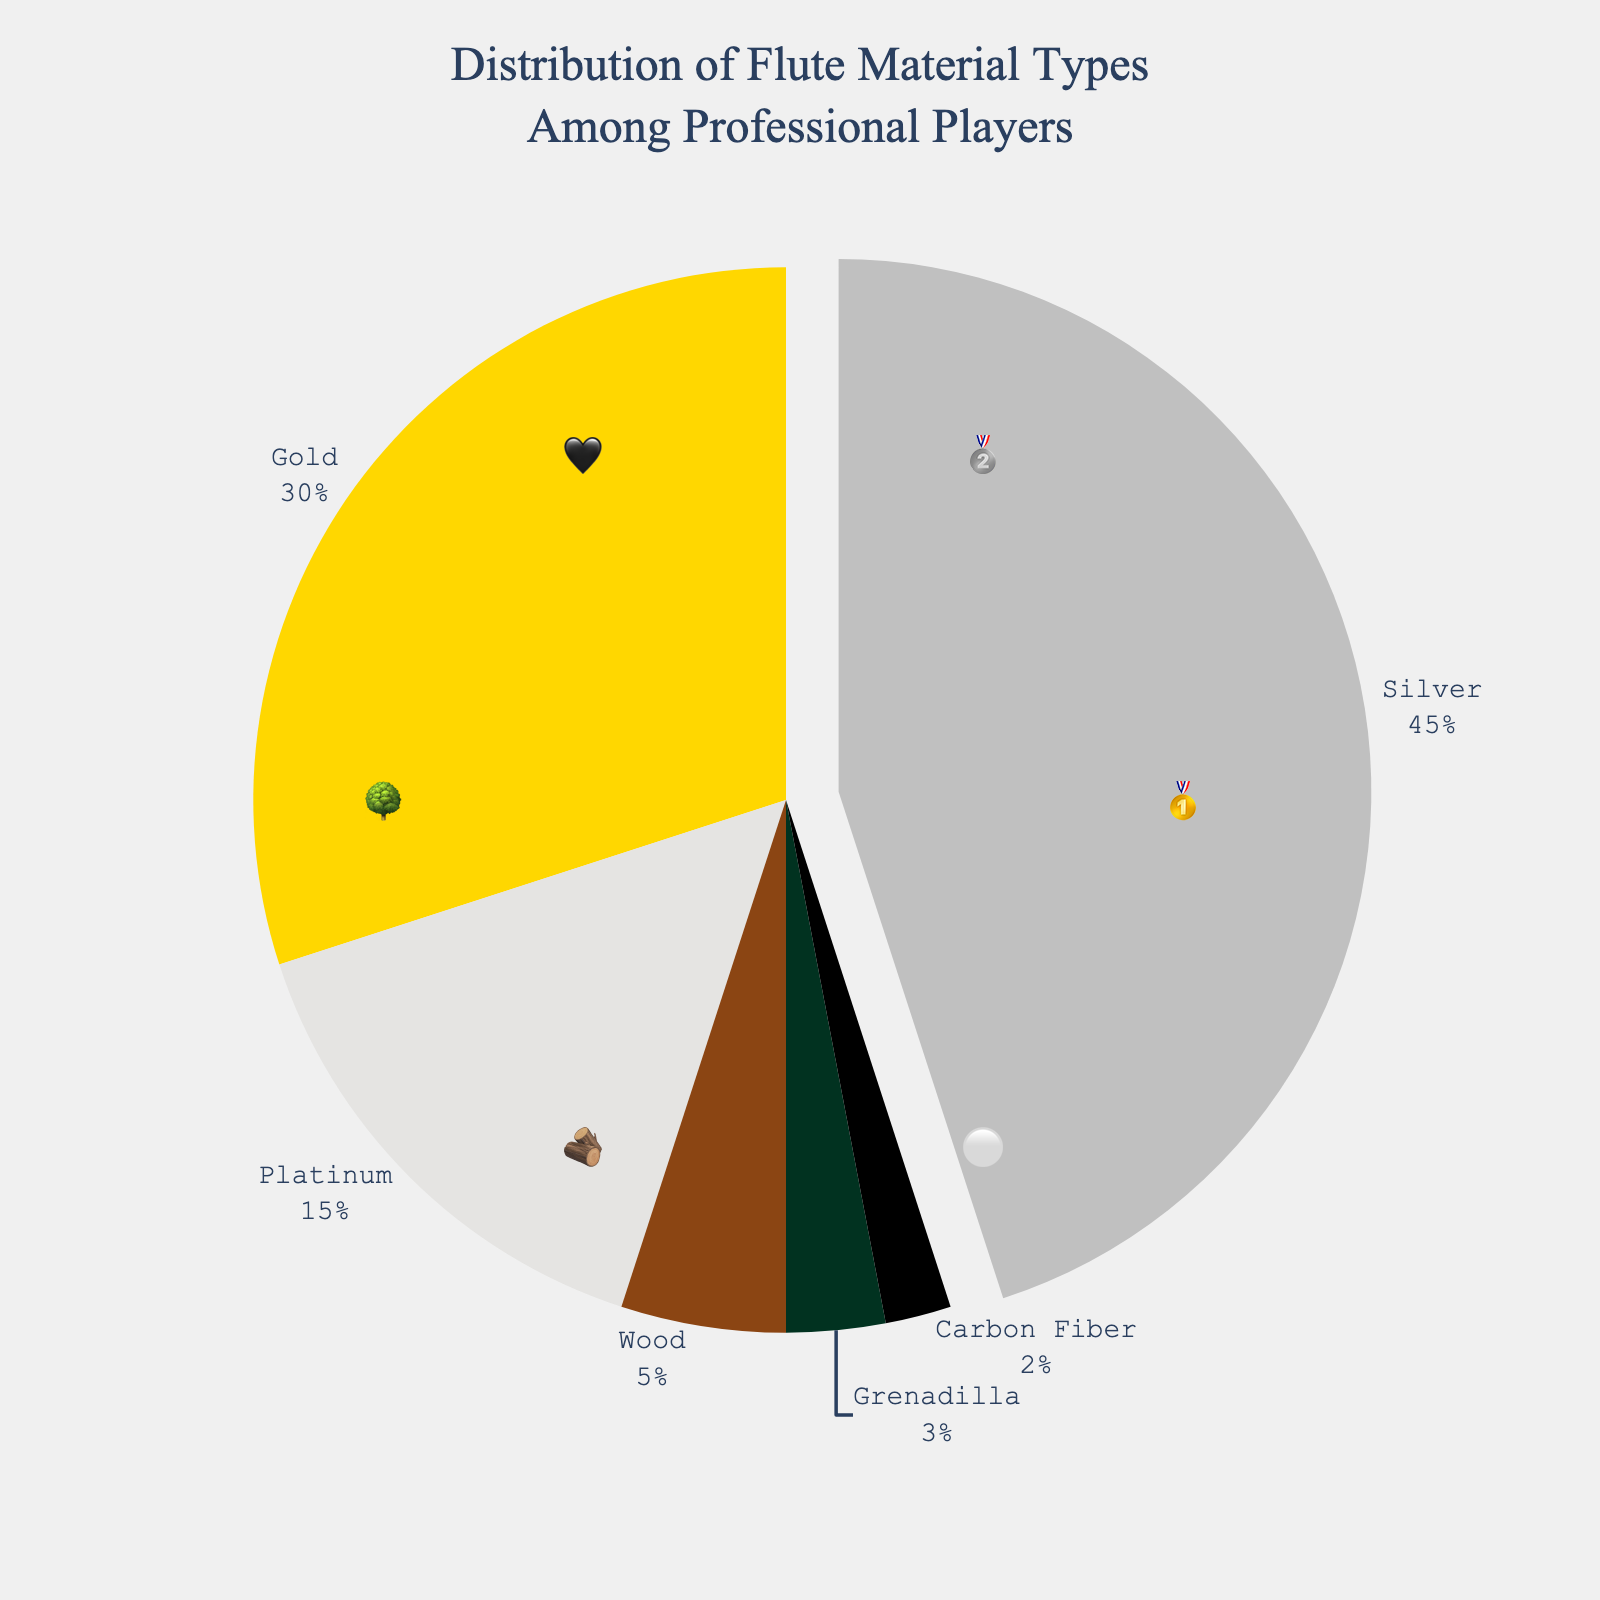What is the title of the chart? The title is located at the top of the figure and provides an overview of the data being represented.
Answer: Distribution of Flute Material Types Among Professional Players Which material is represented by the gold medal emoji? The emoji 🥇 stands for the material column in the data. Gold is associated with the gold medal emoji.
Answer: Gold What percentage of professional players use silver flutes? The percentage is located in the segment labeled 'Silver' on the chart. Silver flutes are used by 45% of professional players.
Answer: 45% How many materials are represented in the chart? The chart shows six distinct segments, representing six different materials.
Answer: 6 Which material has the smallest percentage of usage among professional players? The smallest segment on the chart corresponds to the 'Carbon Fiber' material, which is 2%.
Answer: Carbon Fiber Is the usage of gold flutes greater than the combined usage of wood and grenadilla flutes? Gold flute usage is 30%. Combined usage of wood and grenadilla flutes is calculated as 5% (wood) + 3% (grenadilla) = 8%. 30% is greater than 8%.
Answer: Yes What is the total percentage of players using precious metal flutes (silver, gold, platinum)? Sum the percentages of silver (45%), gold (30%), and platinum (15%). Total: 45% + 30% + 15% = 90%.
Answer: 90% Which flute material has the second highest usage among professional players? The second largest segment on the chart represents gold, at 30%.
Answer: Gold How much more popular are silver flutes compared to platinum flutes? Subtract the percentage of platinum (15%) from the percentage of silver (45%). Difference: 45% - 15% = 30%.
Answer: 30% Which material is represented by the tree emoji? The tree emoji 🌳 stands for the material grenadilla.
Answer: Grenadilla 